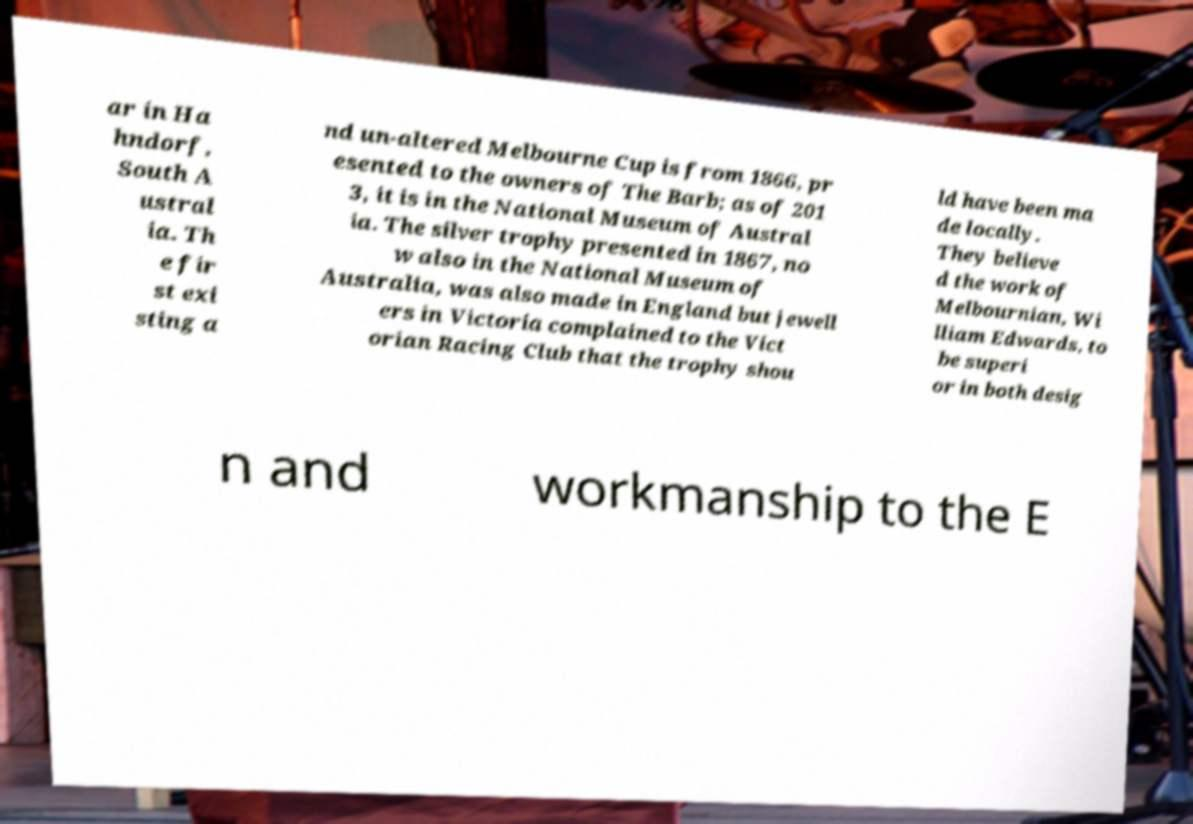Please read and relay the text visible in this image. What does it say? ar in Ha hndorf, South A ustral ia. Th e fir st exi sting a nd un-altered Melbourne Cup is from 1866, pr esented to the owners of The Barb; as of 201 3, it is in the National Museum of Austral ia. The silver trophy presented in 1867, no w also in the National Museum of Australia, was also made in England but jewell ers in Victoria complained to the Vict orian Racing Club that the trophy shou ld have been ma de locally. They believe d the work of Melbournian, Wi lliam Edwards, to be superi or in both desig n and workmanship to the E 